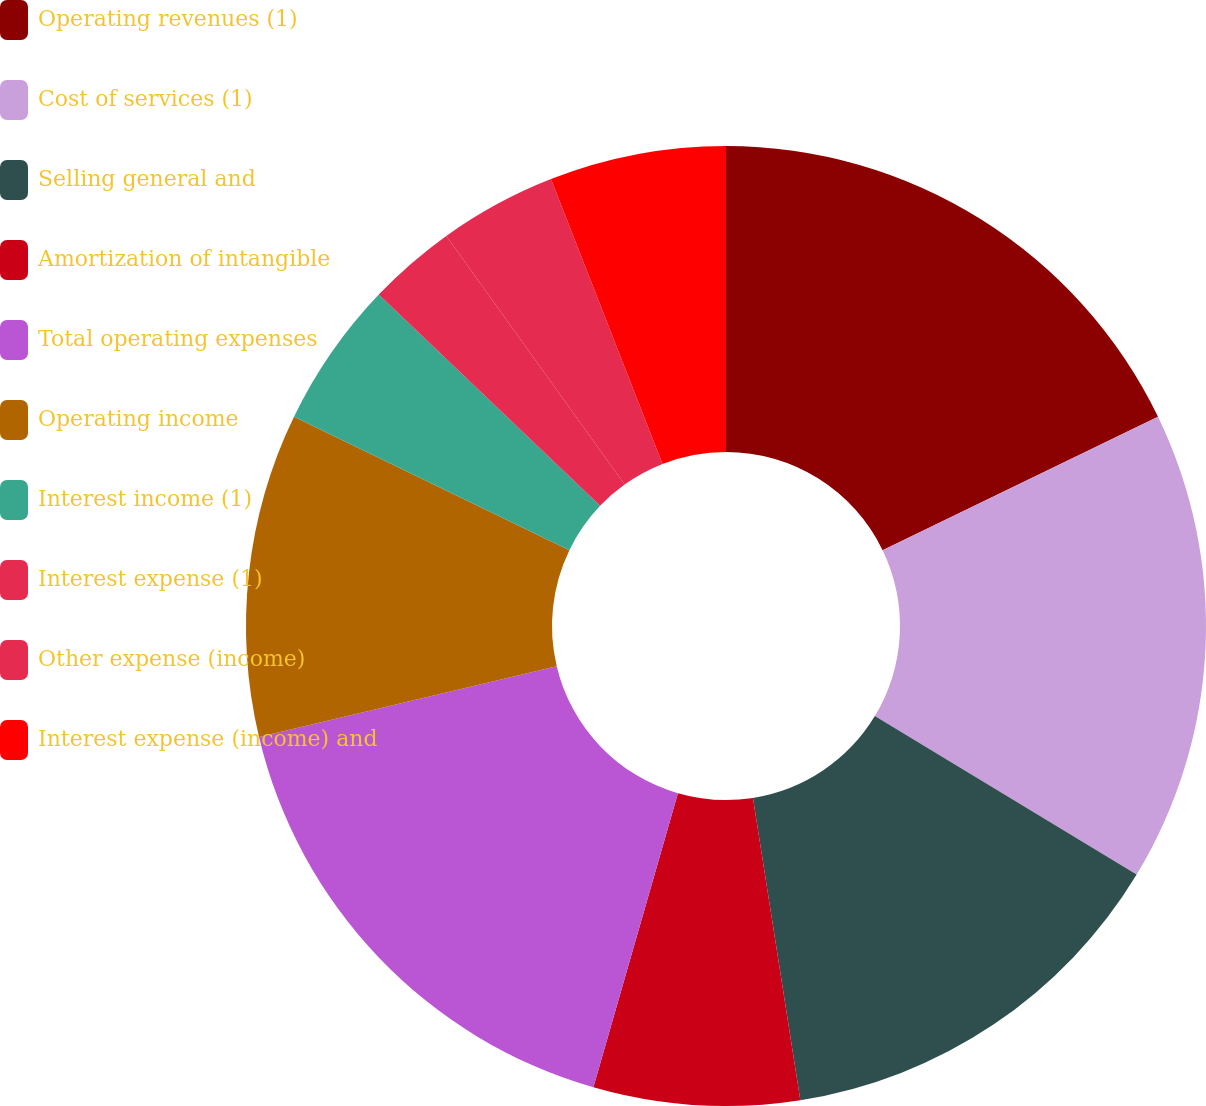<chart> <loc_0><loc_0><loc_500><loc_500><pie_chart><fcel>Operating revenues (1)<fcel>Cost of services (1)<fcel>Selling general and<fcel>Amortization of intangible<fcel>Total operating expenses<fcel>Operating income<fcel>Interest income (1)<fcel>Interest expense (1)<fcel>Other expense (income)<fcel>Interest expense (income) and<nl><fcel>17.82%<fcel>15.84%<fcel>13.86%<fcel>6.93%<fcel>16.83%<fcel>10.89%<fcel>4.95%<fcel>2.97%<fcel>3.96%<fcel>5.94%<nl></chart> 